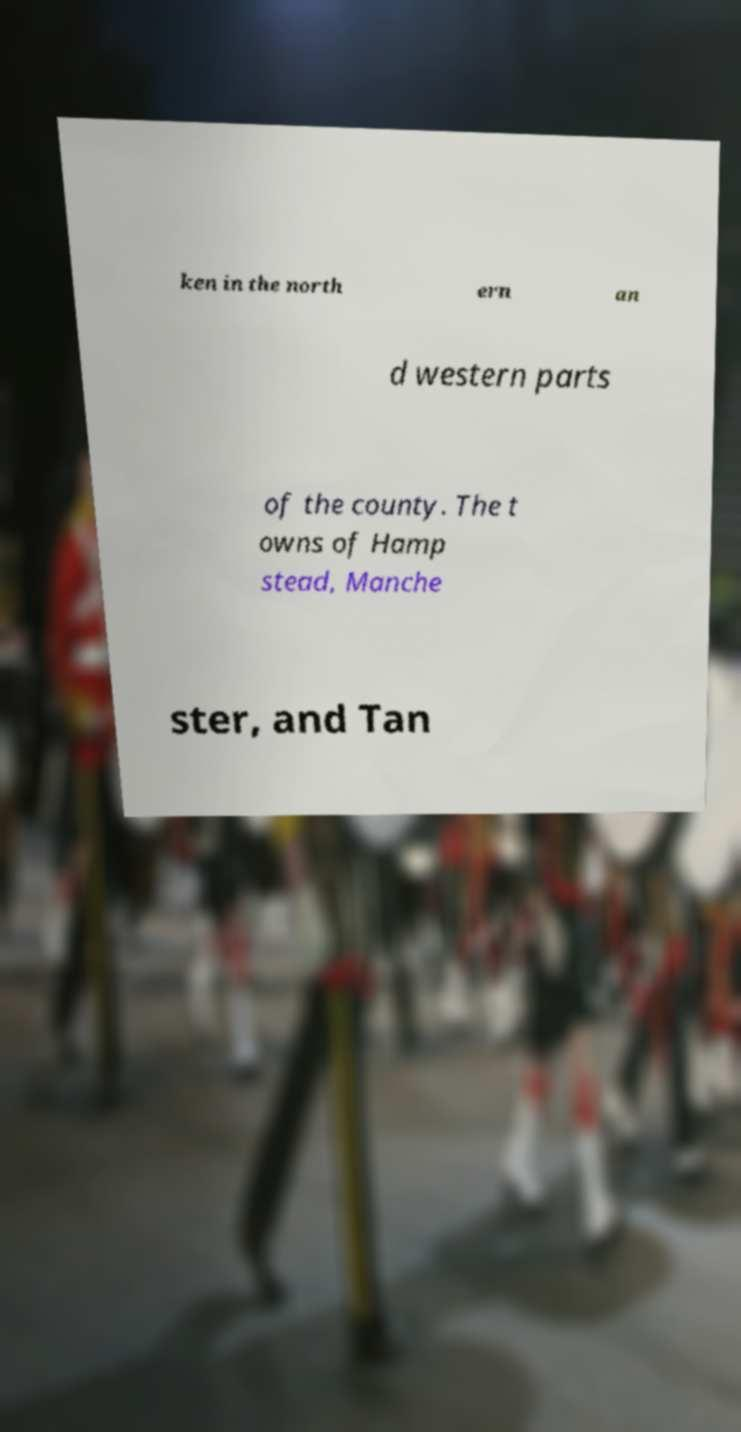Please identify and transcribe the text found in this image. ken in the north ern an d western parts of the county. The t owns of Hamp stead, Manche ster, and Tan 